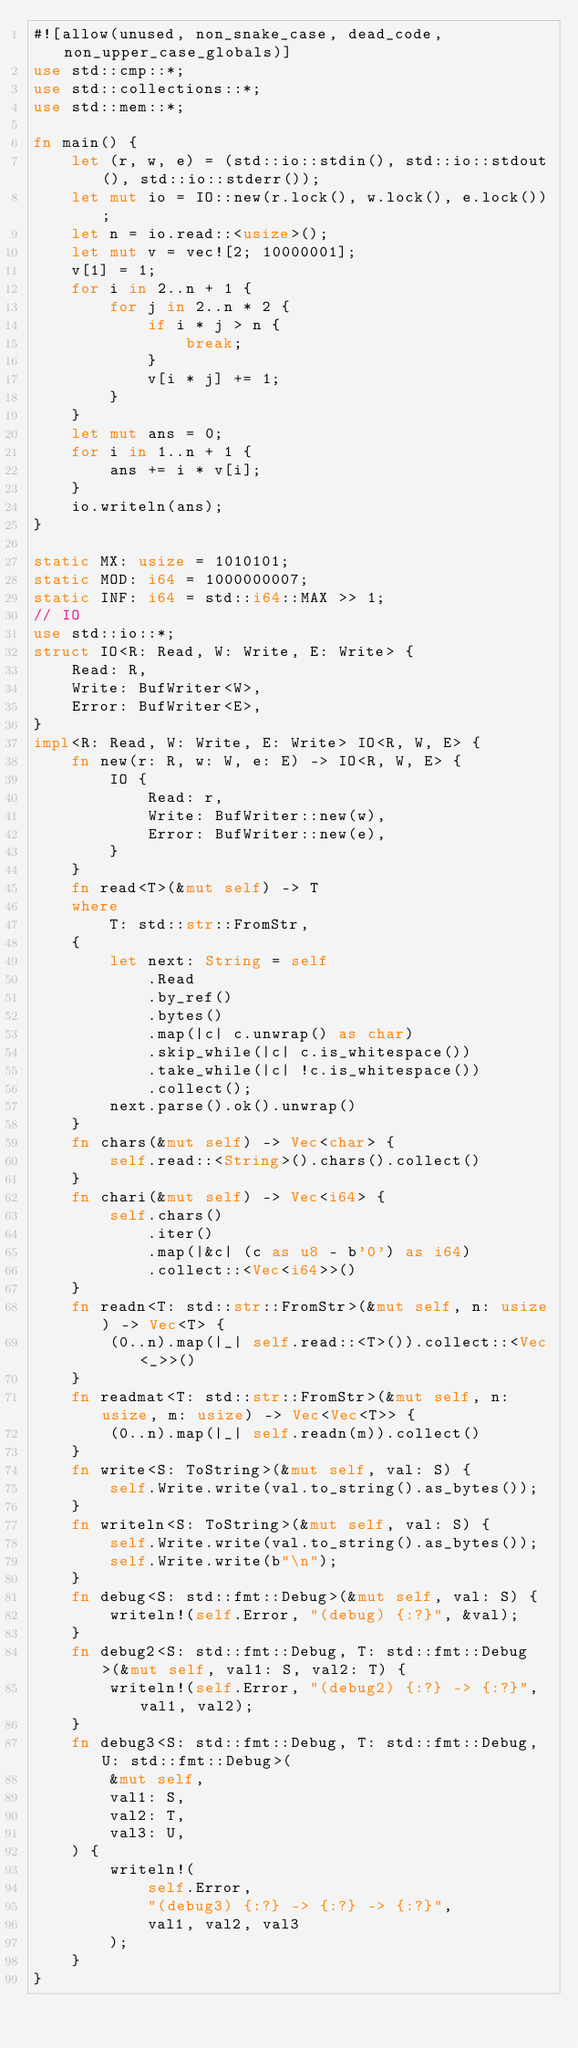Convert code to text. <code><loc_0><loc_0><loc_500><loc_500><_Rust_>#![allow(unused, non_snake_case, dead_code, non_upper_case_globals)]
use std::cmp::*;
use std::collections::*;
use std::mem::*;

fn main() {
    let (r, w, e) = (std::io::stdin(), std::io::stdout(), std::io::stderr());
    let mut io = IO::new(r.lock(), w.lock(), e.lock());
    let n = io.read::<usize>();
    let mut v = vec![2; 10000001];
    v[1] = 1;
    for i in 2..n + 1 {
        for j in 2..n * 2 {
            if i * j > n {
                break;
            }
            v[i * j] += 1;
        }
    }
    let mut ans = 0;
    for i in 1..n + 1 {
        ans += i * v[i];
    }
    io.writeln(ans);
}

static MX: usize = 1010101;
static MOD: i64 = 1000000007;
static INF: i64 = std::i64::MAX >> 1;
// IO
use std::io::*;
struct IO<R: Read, W: Write, E: Write> {
    Read: R,
    Write: BufWriter<W>,
    Error: BufWriter<E>,
}
impl<R: Read, W: Write, E: Write> IO<R, W, E> {
    fn new(r: R, w: W, e: E) -> IO<R, W, E> {
        IO {
            Read: r,
            Write: BufWriter::new(w),
            Error: BufWriter::new(e),
        }
    }
    fn read<T>(&mut self) -> T
    where
        T: std::str::FromStr,
    {
        let next: String = self
            .Read
            .by_ref()
            .bytes()
            .map(|c| c.unwrap() as char)
            .skip_while(|c| c.is_whitespace())
            .take_while(|c| !c.is_whitespace())
            .collect();
        next.parse().ok().unwrap()
    }
    fn chars(&mut self) -> Vec<char> {
        self.read::<String>().chars().collect()
    }
    fn chari(&mut self) -> Vec<i64> {
        self.chars()
            .iter()
            .map(|&c| (c as u8 - b'0') as i64)
            .collect::<Vec<i64>>()
    }
    fn readn<T: std::str::FromStr>(&mut self, n: usize) -> Vec<T> {
        (0..n).map(|_| self.read::<T>()).collect::<Vec<_>>()
    }
    fn readmat<T: std::str::FromStr>(&mut self, n: usize, m: usize) -> Vec<Vec<T>> {
        (0..n).map(|_| self.readn(m)).collect()
    }
    fn write<S: ToString>(&mut self, val: S) {
        self.Write.write(val.to_string().as_bytes());
    }
    fn writeln<S: ToString>(&mut self, val: S) {
        self.Write.write(val.to_string().as_bytes());
        self.Write.write(b"\n");
    }
    fn debug<S: std::fmt::Debug>(&mut self, val: S) {
        writeln!(self.Error, "(debug) {:?}", &val);
    }
    fn debug2<S: std::fmt::Debug, T: std::fmt::Debug>(&mut self, val1: S, val2: T) {
        writeln!(self.Error, "(debug2) {:?} -> {:?}", val1, val2);
    }
    fn debug3<S: std::fmt::Debug, T: std::fmt::Debug, U: std::fmt::Debug>(
        &mut self,
        val1: S,
        val2: T,
        val3: U,
    ) {
        writeln!(
            self.Error,
            "(debug3) {:?} -> {:?} -> {:?}",
            val1, val2, val3
        );
    }
}
</code> 